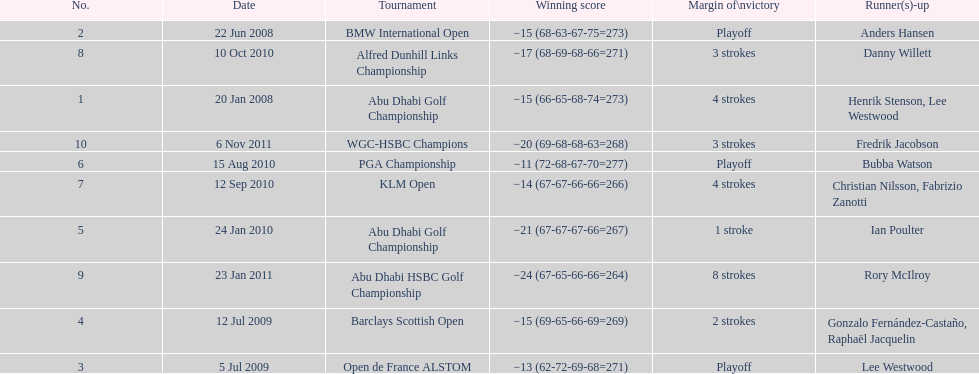How many total tournaments has he won? 10. 